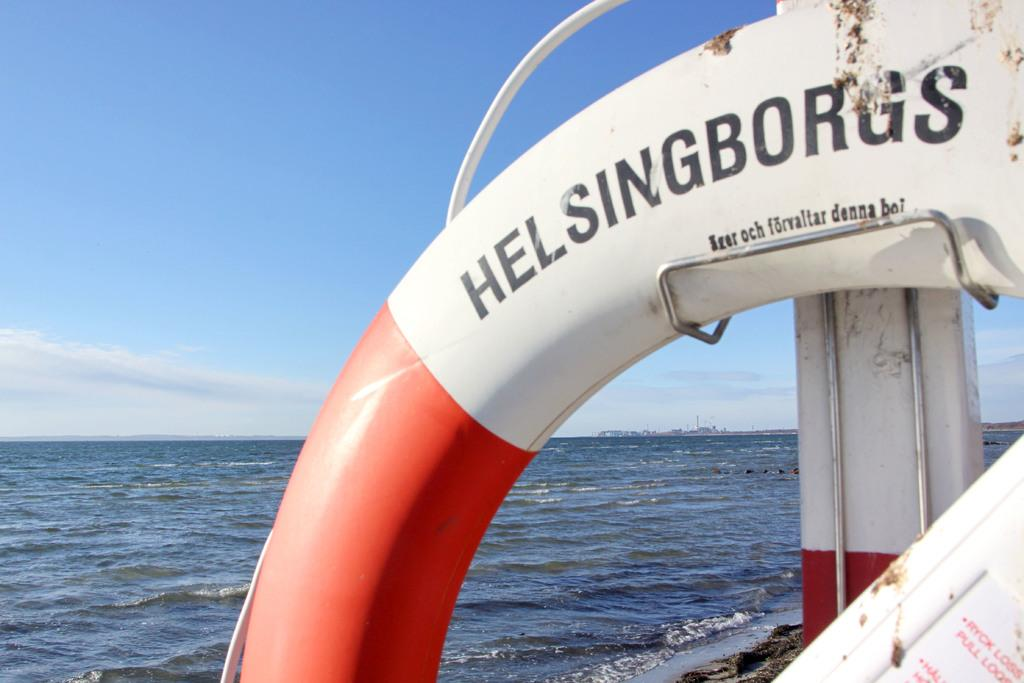<image>
Summarize the visual content of the image. HelsingBorgs Written on a red and white ship in the water. 